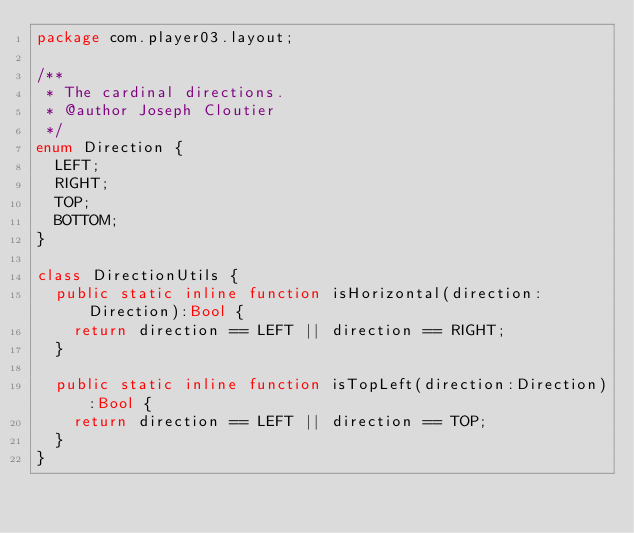Convert code to text. <code><loc_0><loc_0><loc_500><loc_500><_Haxe_>package com.player03.layout;

/**
 * The cardinal directions.
 * @author Joseph Cloutier
 */
enum Direction {
	LEFT;
	RIGHT;
	TOP;
	BOTTOM;
}

class DirectionUtils {
	public static inline function isHorizontal(direction:Direction):Bool {
		return direction == LEFT || direction == RIGHT;
	}
	
	public static inline function isTopLeft(direction:Direction):Bool {
		return direction == LEFT || direction == TOP;
	}
}
</code> 